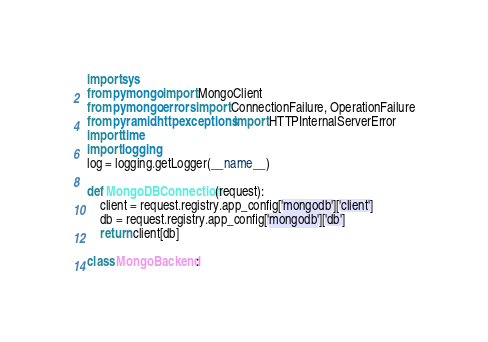Convert code to text. <code><loc_0><loc_0><loc_500><loc_500><_Python_>import sys
from pymongo import MongoClient
from pymongo.errors import ConnectionFailure, OperationFailure
from pyramid.httpexceptions import HTTPInternalServerError
import time
import logging
log = logging.getLogger(__name__)

def MongoDBConnection(request):
    client = request.registry.app_config['mongodb']['client']
    db = request.registry.app_config['mongodb']['db']
    return client[db]

class MongoBackend:</code> 